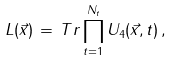<formula> <loc_0><loc_0><loc_500><loc_500>L ( \vec { x } ) \, = \, T r \prod _ { t = 1 } ^ { N _ { t } } U _ { 4 } ( \vec { x } , t ) \, ,</formula> 